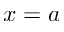<formula> <loc_0><loc_0><loc_500><loc_500>x = a</formula> 